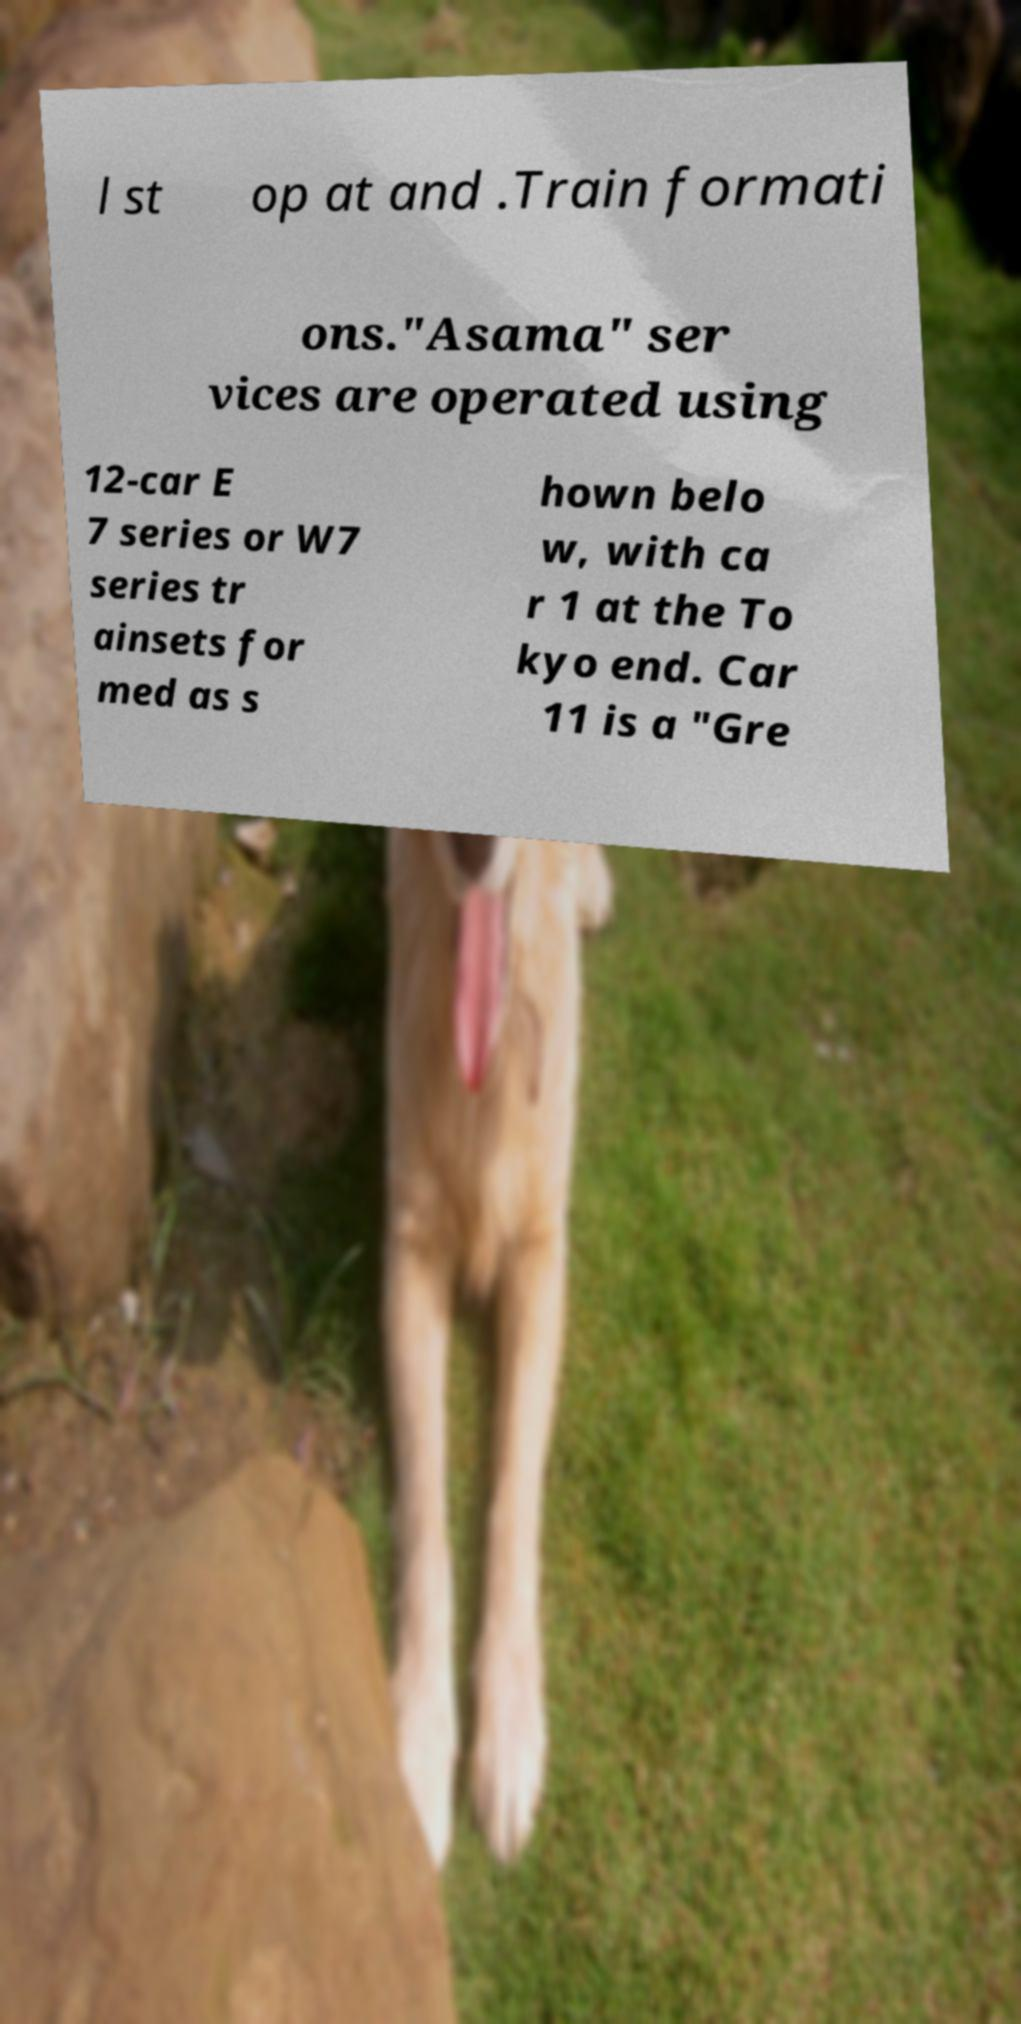Can you accurately transcribe the text from the provided image for me? l st op at and .Train formati ons."Asama" ser vices are operated using 12-car E 7 series or W7 series tr ainsets for med as s hown belo w, with ca r 1 at the To kyo end. Car 11 is a "Gre 